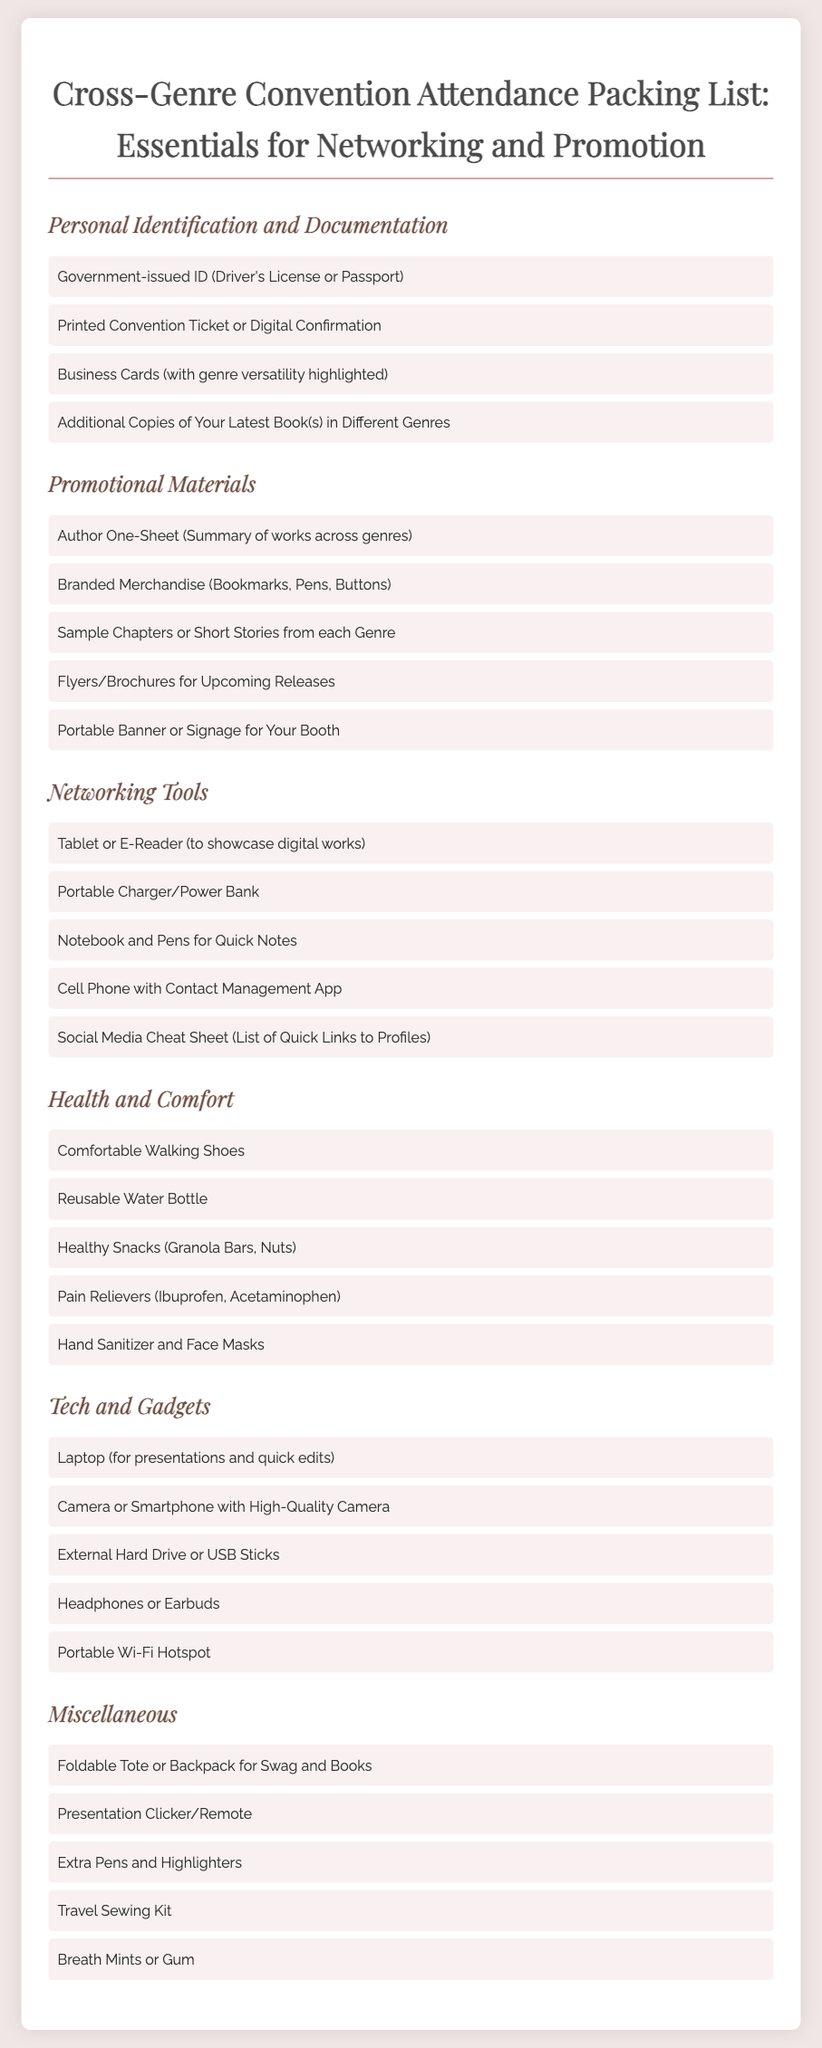What should you bring for personal identification? The document lists several items under personal identification, including a government-issued ID and a printed convention ticket.
Answer: Government-issued ID How many categories are included in the packing list? The document outlines six distinct categories covering various packing essentials.
Answer: Six What type of promotional material is recommended? One suggested item for promotional materials is an author one-sheet summarizing works across genres.
Answer: Author One-Sheet Which item is suggested for health and comfort? A suggested item in the health and comfort category is comfortable walking shoes for event attendees.
Answer: Comfortable Walking Shoes What tech gadget should you bring for presentations? The packing list indicates that a laptop is essential for presentations and quick edits during the convention.
Answer: Laptop What is an example of a networking tool listed? The document mentions several networking tools, including a cell phone with a contact management app for easier networking.
Answer: Cell Phone How many promotional materials are suggested in total? The list gives a total of five suggested promotional materials for effective promotion at the convention.
Answer: Five What kind of charger is recommended in the networking tools section? The document specifies a portable charger or power bank as an essential item for staying powered up at the event.
Answer: Portable Charger What is an example of a miscellaneous item you might need? One item in the miscellaneous category is a travel sewing kit for dealing with any last-minute wardrobe malfunctions.
Answer: Travel Sewing Kit 